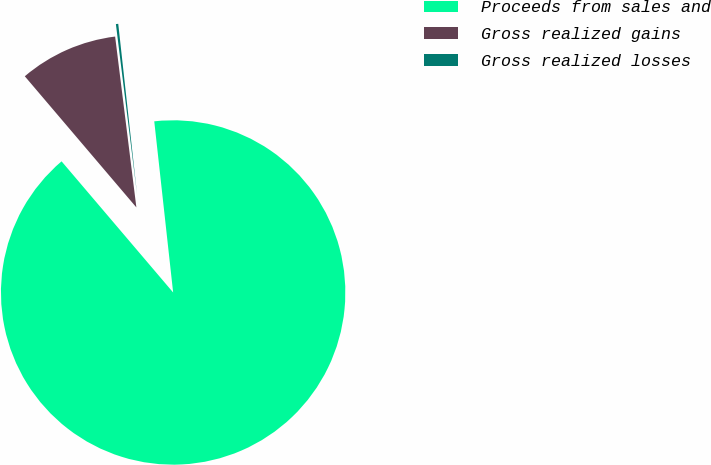Convert chart to OTSL. <chart><loc_0><loc_0><loc_500><loc_500><pie_chart><fcel>Proceeds from sales and<fcel>Gross realized gains<fcel>Gross realized losses<nl><fcel>90.52%<fcel>9.25%<fcel>0.22%<nl></chart> 